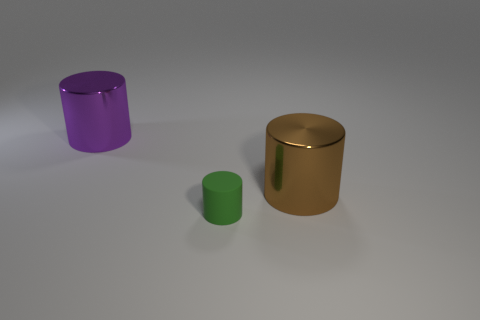Add 1 big cylinders. How many objects exist? 4 Subtract all small matte things. Subtract all big purple metal objects. How many objects are left? 1 Add 1 brown shiny things. How many brown shiny things are left? 2 Add 1 large things. How many large things exist? 3 Subtract 0 yellow cubes. How many objects are left? 3 